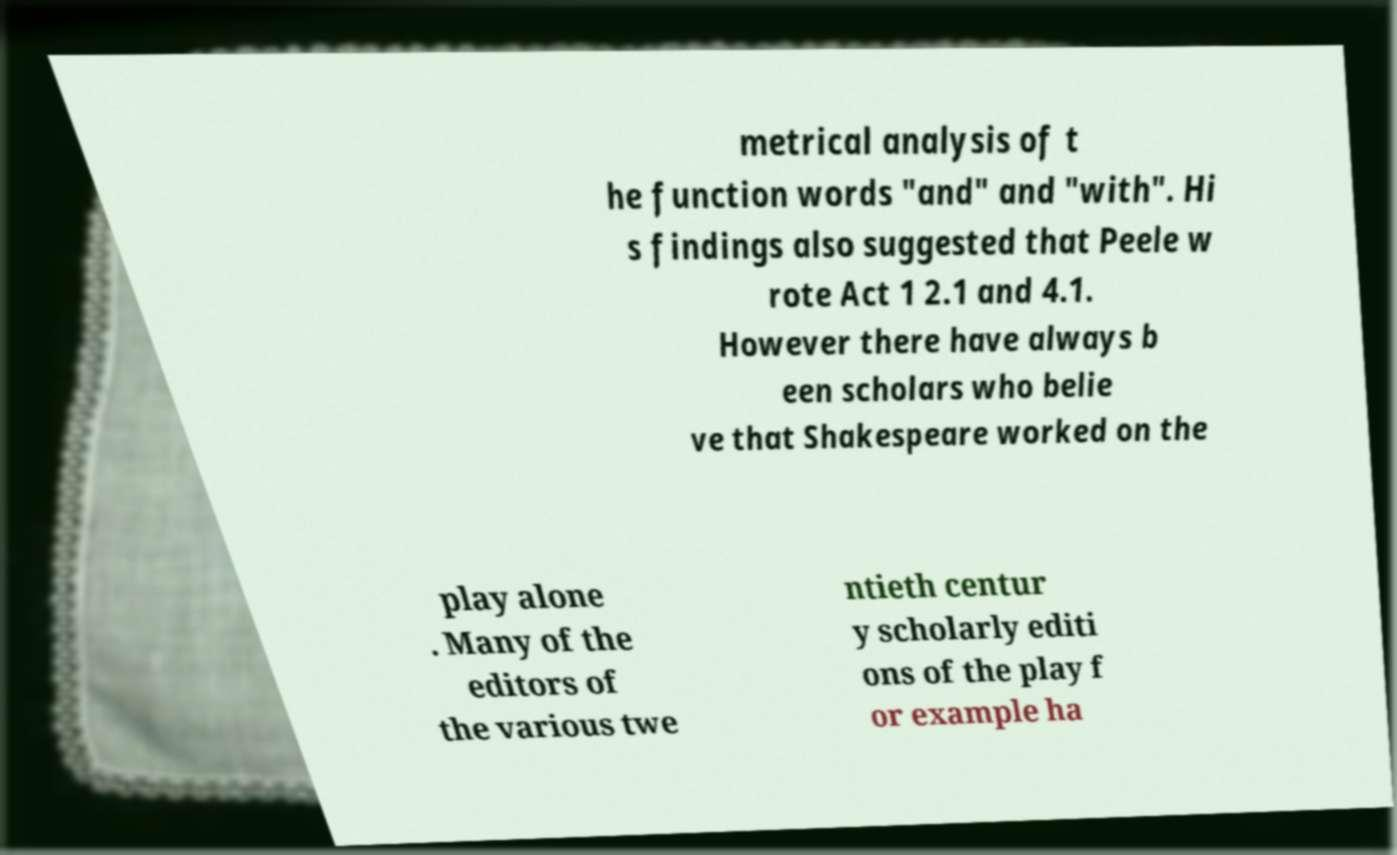Please read and relay the text visible in this image. What does it say? metrical analysis of t he function words "and" and "with". Hi s findings also suggested that Peele w rote Act 1 2.1 and 4.1. However there have always b een scholars who belie ve that Shakespeare worked on the play alone . Many of the editors of the various twe ntieth centur y scholarly editi ons of the play f or example ha 